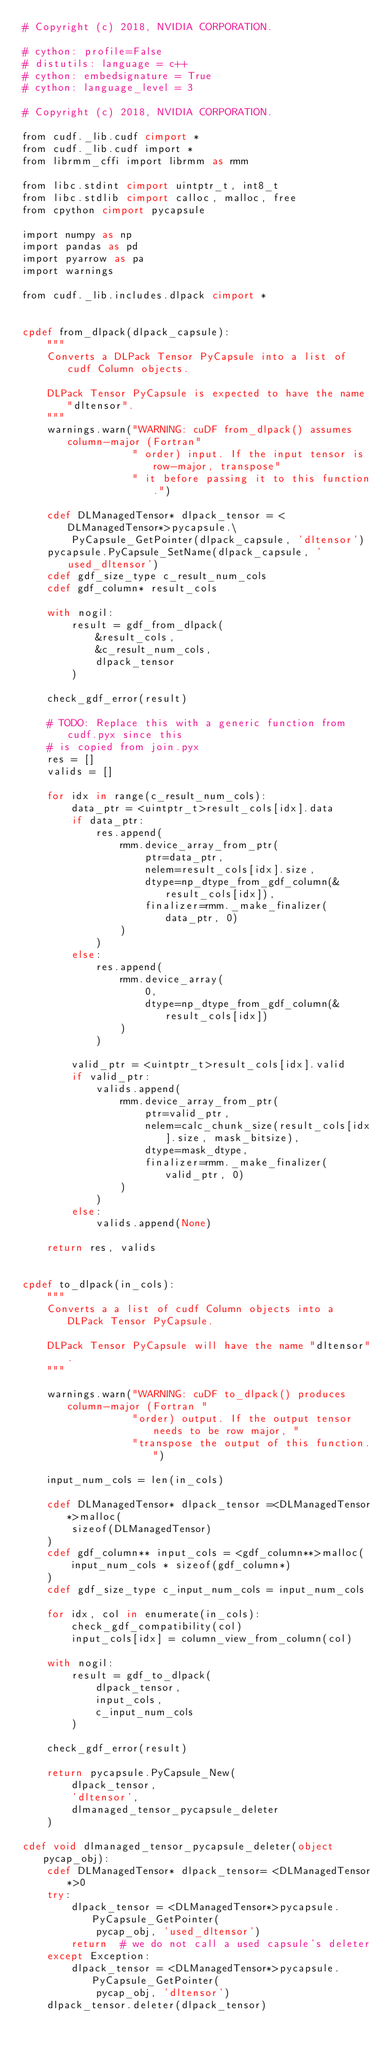Convert code to text. <code><loc_0><loc_0><loc_500><loc_500><_Cython_># Copyright (c) 2018, NVIDIA CORPORATION.

# cython: profile=False
# distutils: language = c++
# cython: embedsignature = True
# cython: language_level = 3

# Copyright (c) 2018, NVIDIA CORPORATION.

from cudf._lib.cudf cimport *
from cudf._lib.cudf import *
from librmm_cffi import librmm as rmm

from libc.stdint cimport uintptr_t, int8_t
from libc.stdlib cimport calloc, malloc, free
from cpython cimport pycapsule

import numpy as np
import pandas as pd
import pyarrow as pa
import warnings

from cudf._lib.includes.dlpack cimport *


cpdef from_dlpack(dlpack_capsule):
    """
    Converts a DLPack Tensor PyCapsule into a list of cudf Column objects.

    DLPack Tensor PyCapsule is expected to have the name "dltensor".
    """
    warnings.warn("WARNING: cuDF from_dlpack() assumes column-major (Fortran"
                  " order) input. If the input tensor is row-major, transpose"
                  " it before passing it to this function.")

    cdef DLManagedTensor* dlpack_tensor = <DLManagedTensor*>pycapsule.\
        PyCapsule_GetPointer(dlpack_capsule, 'dltensor')
    pycapsule.PyCapsule_SetName(dlpack_capsule, 'used_dltensor')
    cdef gdf_size_type c_result_num_cols
    cdef gdf_column* result_cols

    with nogil:
        result = gdf_from_dlpack(
            &result_cols,
            &c_result_num_cols,
            dlpack_tensor
        )

    check_gdf_error(result)

    # TODO: Replace this with a generic function from cudf.pyx since this
    # is copied from join.pyx
    res = []
    valids = []

    for idx in range(c_result_num_cols):
        data_ptr = <uintptr_t>result_cols[idx].data
        if data_ptr:
            res.append(
                rmm.device_array_from_ptr(
                    ptr=data_ptr,
                    nelem=result_cols[idx].size,
                    dtype=np_dtype_from_gdf_column(&result_cols[idx]),
                    finalizer=rmm._make_finalizer(data_ptr, 0)
                )
            )
        else:
            res.append(
                rmm.device_array(
                    0,
                    dtype=np_dtype_from_gdf_column(&result_cols[idx])
                )
            )

        valid_ptr = <uintptr_t>result_cols[idx].valid
        if valid_ptr:
            valids.append(
                rmm.device_array_from_ptr(
                    ptr=valid_ptr,
                    nelem=calc_chunk_size(result_cols[idx].size, mask_bitsize),
                    dtype=mask_dtype,
                    finalizer=rmm._make_finalizer(valid_ptr, 0)
                )
            )
        else:
            valids.append(None)

    return res, valids


cpdef to_dlpack(in_cols):
    """
    Converts a a list of cudf Column objects into a DLPack Tensor PyCapsule.

    DLPack Tensor PyCapsule will have the name "dltensor".
    """

    warnings.warn("WARNING: cuDF to_dlpack() produces column-major (Fortran "
                  "order) output. If the output tensor needs to be row major, "
                  "transpose the output of this function.")

    input_num_cols = len(in_cols)

    cdef DLManagedTensor* dlpack_tensor =<DLManagedTensor*>malloc(
        sizeof(DLManagedTensor)
    )
    cdef gdf_column** input_cols = <gdf_column**>malloc(
        input_num_cols * sizeof(gdf_column*)
    )
    cdef gdf_size_type c_input_num_cols = input_num_cols

    for idx, col in enumerate(in_cols):
        check_gdf_compatibility(col)
        input_cols[idx] = column_view_from_column(col)

    with nogil:
        result = gdf_to_dlpack(
            dlpack_tensor,
            input_cols,
            c_input_num_cols
        )

    check_gdf_error(result)

    return pycapsule.PyCapsule_New(
        dlpack_tensor,
        'dltensor',
        dlmanaged_tensor_pycapsule_deleter
    )

cdef void dlmanaged_tensor_pycapsule_deleter(object pycap_obj):
    cdef DLManagedTensor* dlpack_tensor= <DLManagedTensor*>0
    try:
        dlpack_tensor = <DLManagedTensor*>pycapsule.PyCapsule_GetPointer(
            pycap_obj, 'used_dltensor')
        return  # we do not call a used capsule's deleter
    except Exception:
        dlpack_tensor = <DLManagedTensor*>pycapsule.PyCapsule_GetPointer(
            pycap_obj, 'dltensor')
    dlpack_tensor.deleter(dlpack_tensor)
</code> 